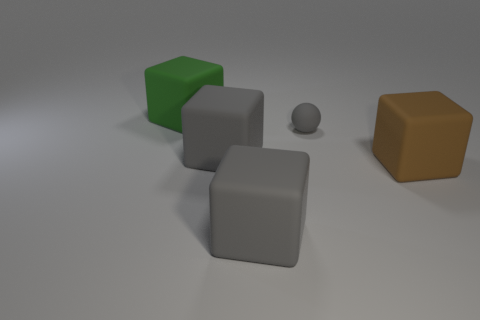Add 2 green matte blocks. How many objects exist? 7 Subtract all purple blocks. Subtract all cyan balls. How many blocks are left? 4 Subtract all balls. How many objects are left? 4 Add 1 spheres. How many spheres are left? 2 Add 1 gray matte objects. How many gray matte objects exist? 4 Subtract 1 green cubes. How many objects are left? 4 Subtract all big objects. Subtract all large brown rubber objects. How many objects are left? 0 